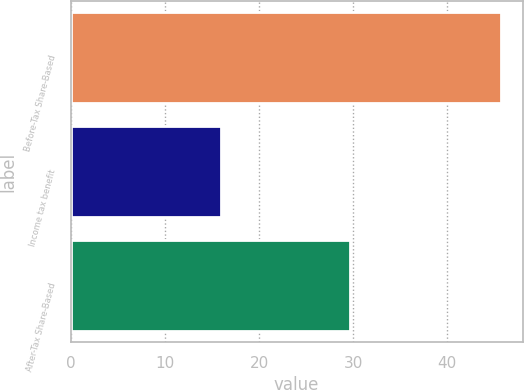<chart> <loc_0><loc_0><loc_500><loc_500><bar_chart><fcel>Before-Tax Share-Based<fcel>Income tax benefit<fcel>After-Tax Share-Based<nl><fcel>45.7<fcel>16<fcel>29.7<nl></chart> 